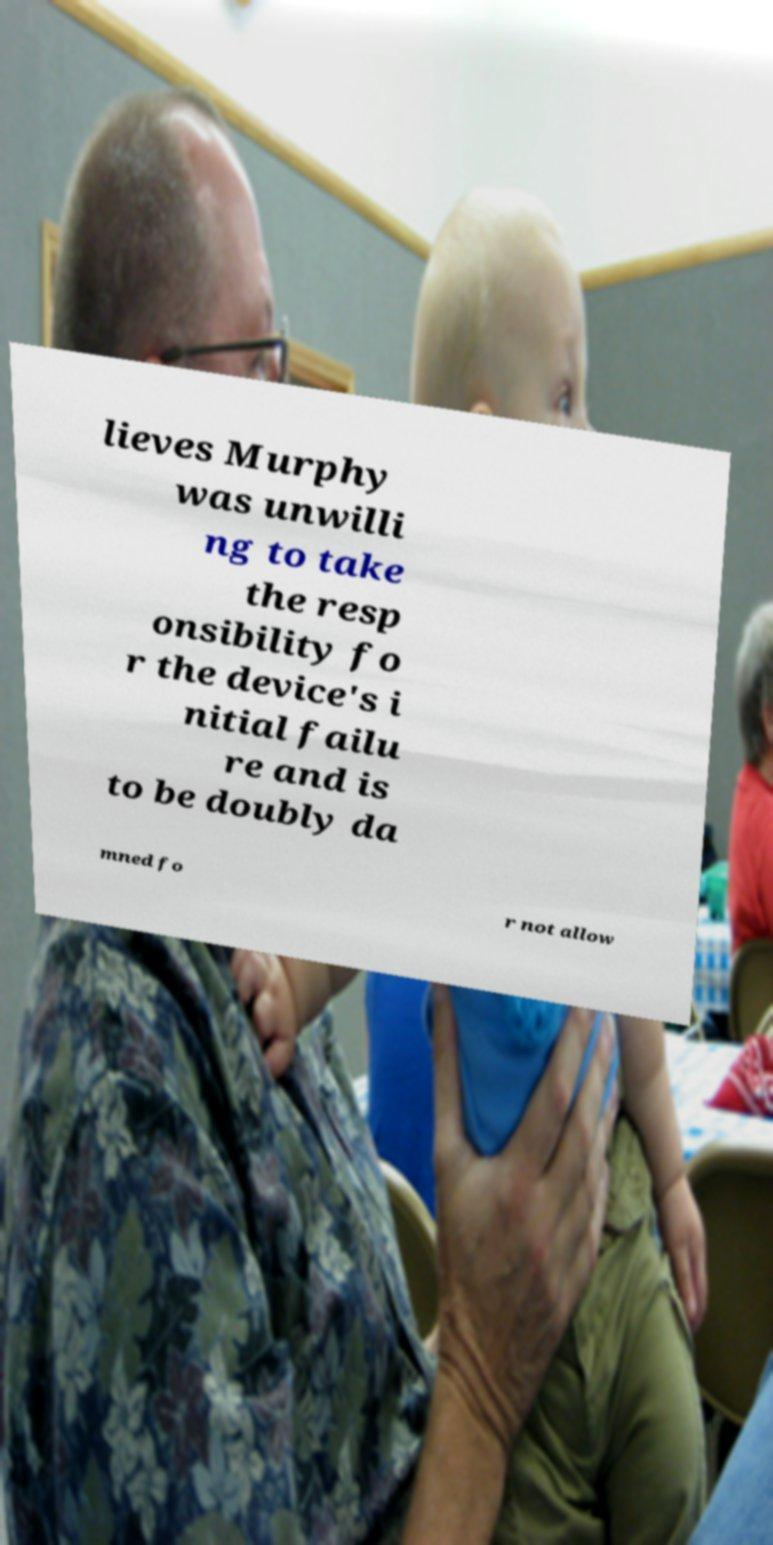Can you accurately transcribe the text from the provided image for me? lieves Murphy was unwilli ng to take the resp onsibility fo r the device's i nitial failu re and is to be doubly da mned fo r not allow 